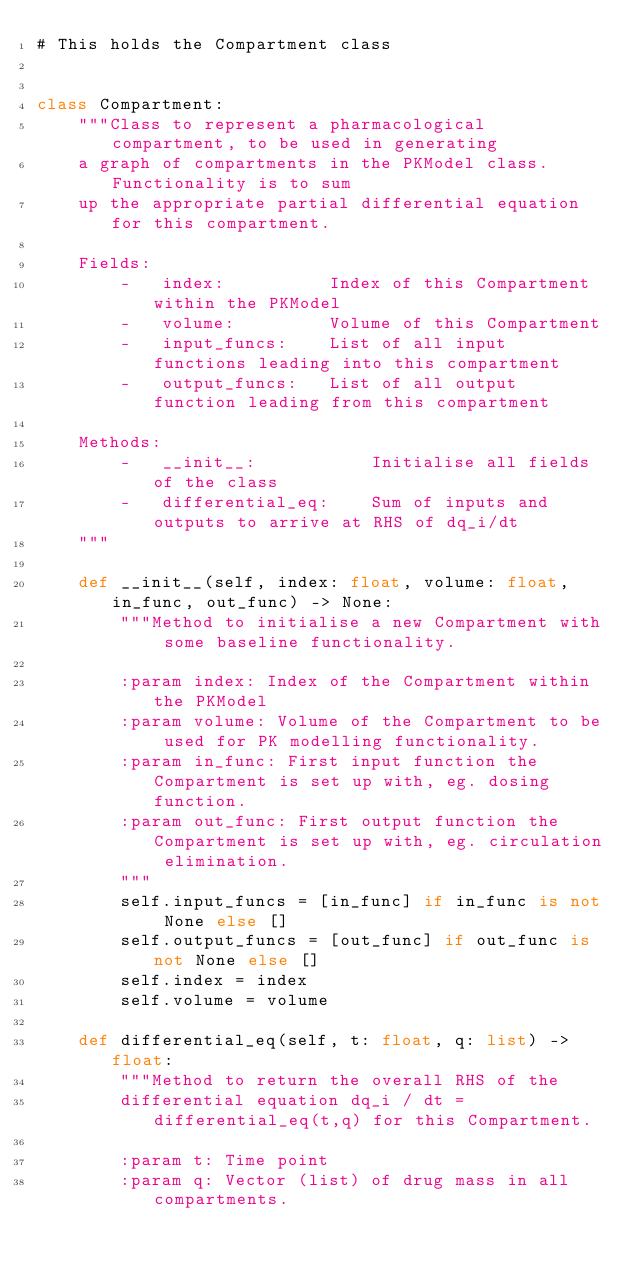<code> <loc_0><loc_0><loc_500><loc_500><_Python_># This holds the Compartment class


class Compartment:
    """Class to represent a pharmacological compartment, to be used in generating
    a graph of compartments in the PKModel class. Functionality is to sum
    up the appropriate partial differential equation for this compartment.

    Fields:
        -   index:          Index of this Compartment within the PKModel
        -   volume:         Volume of this Compartment
        -   input_funcs:    List of all input functions leading into this compartment
        -   output_funcs:   List of all output function leading from this compartment

    Methods:
        -   __init__:           Initialise all fields of the class
        -   differential_eq:    Sum of inputs and outputs to arrive at RHS of dq_i/dt
    """

    def __init__(self, index: float, volume: float, in_func, out_func) -> None:
        """Method to initialise a new Compartment with some baseline functionality.

        :param index: Index of the Compartment within the PKModel
        :param volume: Volume of the Compartment to be used for PK modelling functionality.
        :param in_func: First input function the Compartment is set up with, eg. dosing function.
        :param out_func: First output function the Compartment is set up with, eg. circulation elimination.
        """
        self.input_funcs = [in_func] if in_func is not None else []
        self.output_funcs = [out_func] if out_func is not None else []
        self.index = index
        self.volume = volume

    def differential_eq(self, t: float, q: list) -> float:
        """Method to return the overall RHS of the
        differential equation dq_i / dt = differential_eq(t,q) for this Compartment.

        :param t: Time point
        :param q: Vector (list) of drug mass in all compartments.</code> 